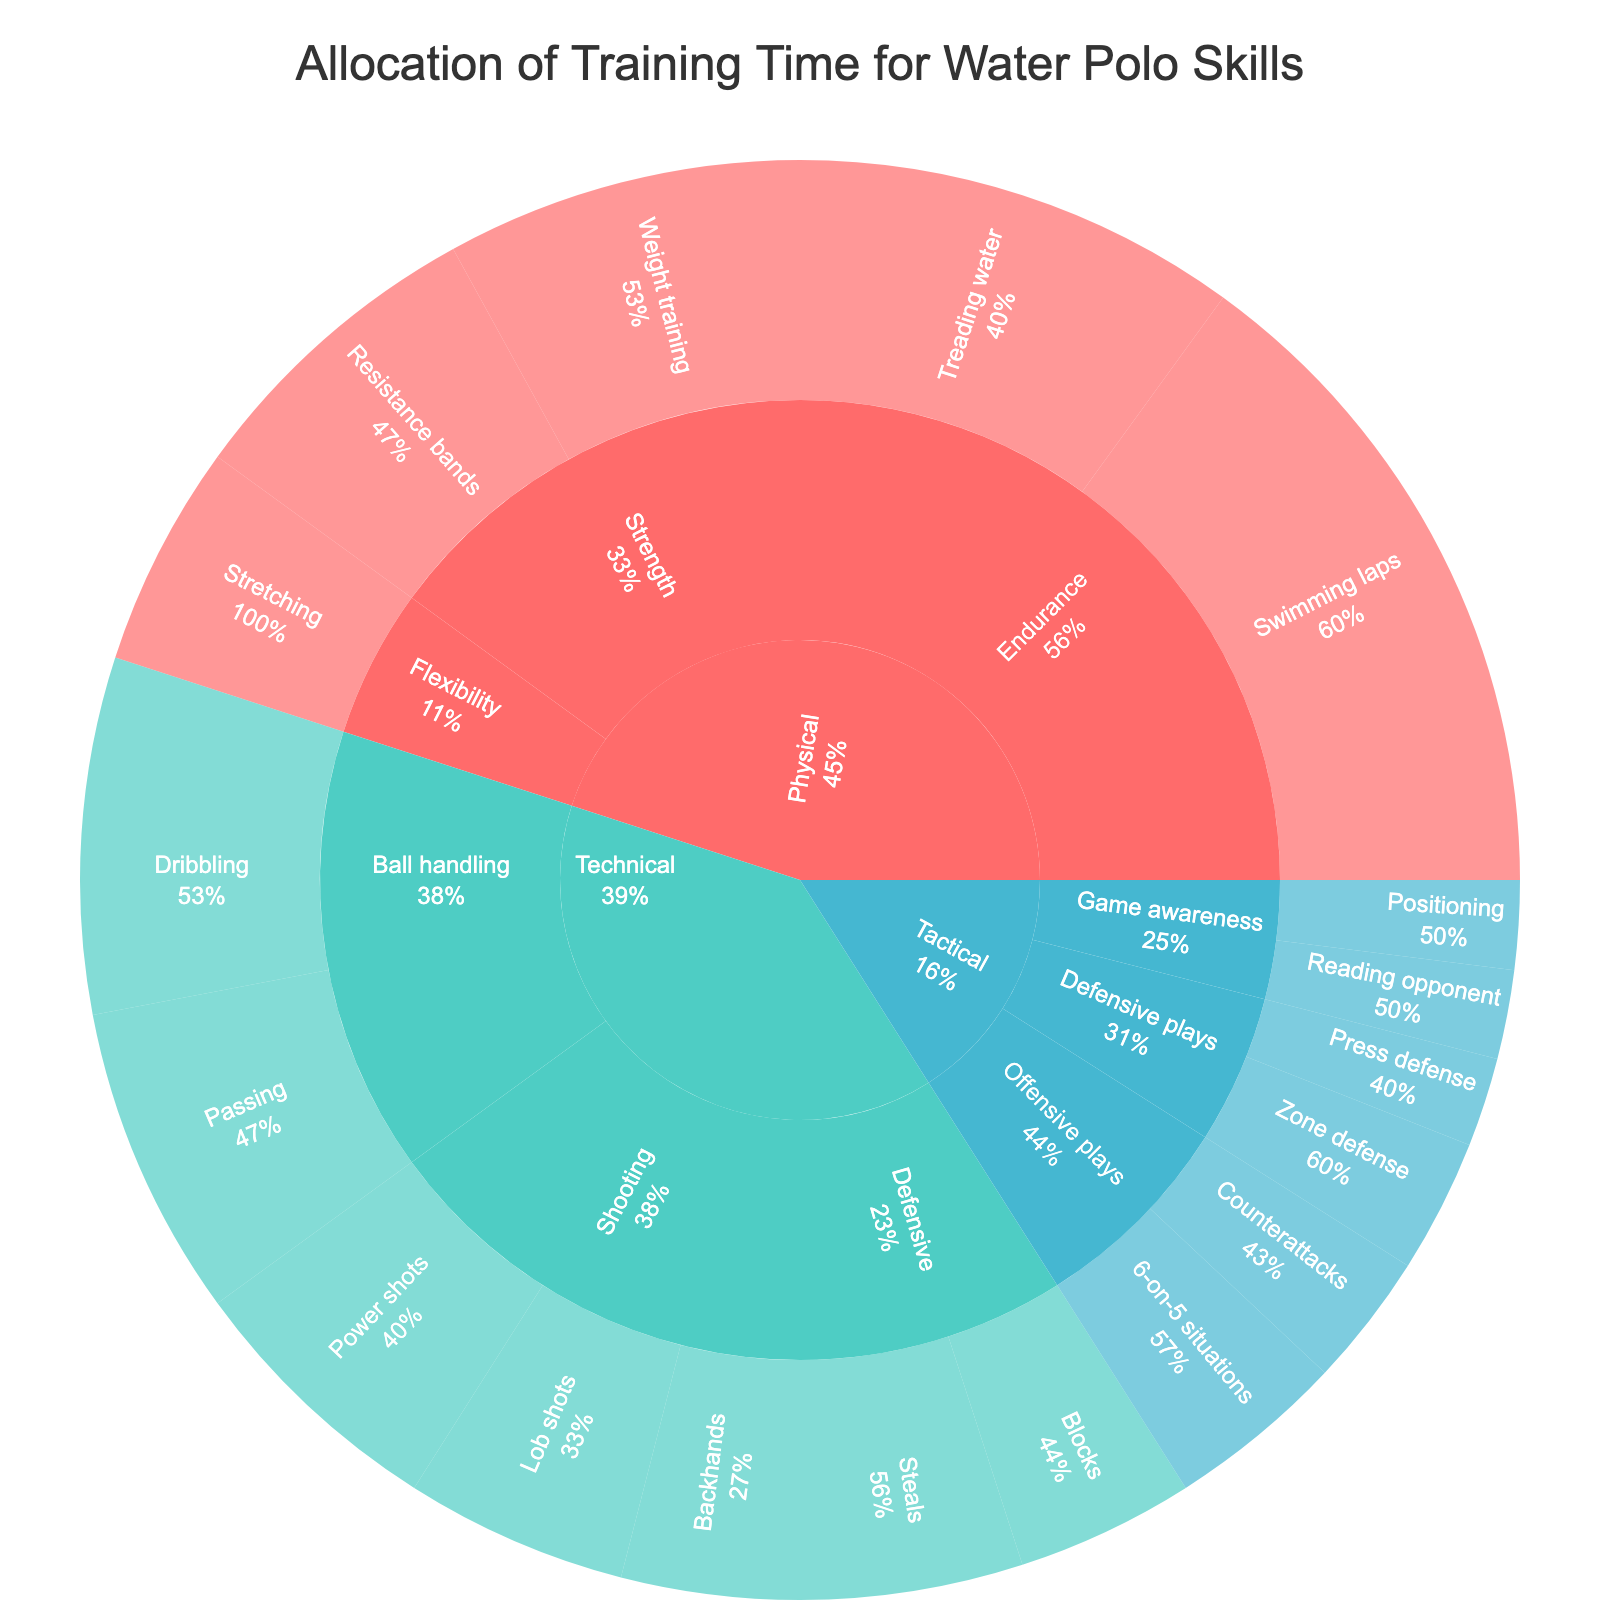What is the title of the figure? The title is typically at the top of the figure, prominently displayed to describe the content.
Answer: "Allocation of Training Time for Water Polo Skills" Which category has the largest overall percentage allocation? To find this, look for the section with the largest area and see which category it belongs to.
Answer: Physical What is the total percentage allocated to Technical skills? Add the individual percentages under the Technical category: 8 (Dribbling) + 7 (Passing) + 6 (Power shots) + 5 (Lob shots) + 4 (Backhands) + 5 (Steals) + 4 (Blocks).
Answer: 39% Which subcategory under Tactical has the most training time allocated? Identify the subcategory under Tactical with the highest percentage by looking at the size of the sections.
Answer: Offensive plays How much more time is allocated to Swimming laps compared to Treading water? The difference between the percentages of Swimming laps (15%) and Treading water (10%) is calculated.
Answer: 5% What percentage of the total training time is allocated to Game awareness skills? Sum the percentages for Reading opponent (2%) and Positioning (2%) under Game awareness.
Answer: 4% Which technical skill has the smallest percentage allocation? Compare the percentages of all skills under the Technical category and identify the smallest one.
Answer: Backhands Are more percentages allocated to physical endurance or flexibility exercises? Compare the sum of percentages in Endurance (Swimming laps and Treading water) with Flexibility (Stretching).
Answer: Endurance Calculate the difference in allocation between Physical Strength and Tactical Defensive plays. Sum the Physical Strength percentages (Weight training + Resistance bands) and compare with the sum of Tactical Defensive plays (Zone defense + Press defense).
Answer: 10% - 5% = 5% How does the allocation to Ball handling compare with Shooting under the Technical category? Sum the percentages for Ball handling (Dribbling, Passing) and Shooting (Power shots, Lob shots, Backhands) and compare them.
Answer: Ball handling: 15%, Shooting: 15% 